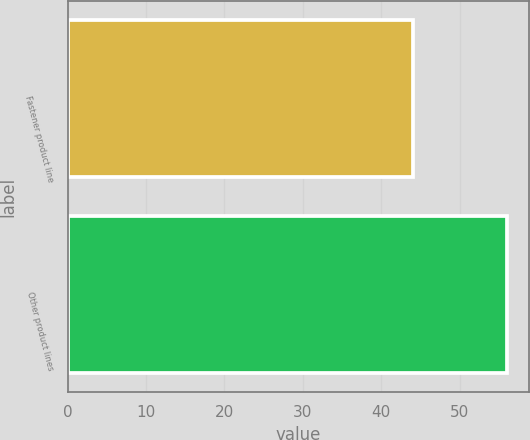Convert chart. <chart><loc_0><loc_0><loc_500><loc_500><bar_chart><fcel>Fastener product line<fcel>Other product lines<nl><fcel>44<fcel>56<nl></chart> 